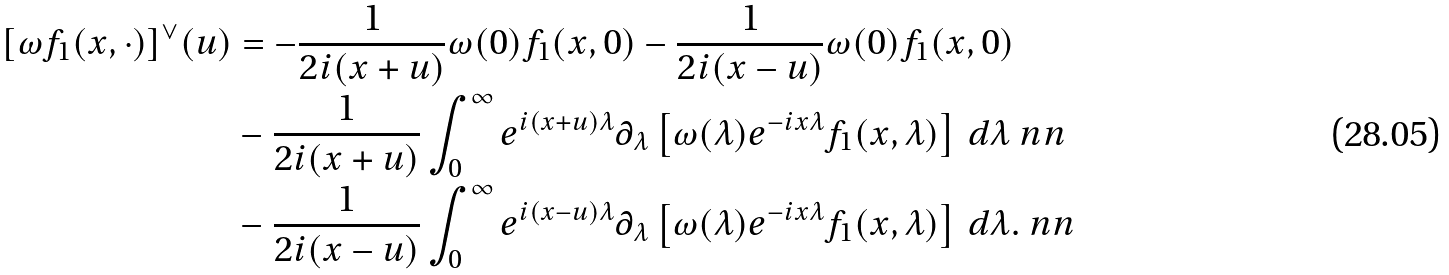<formula> <loc_0><loc_0><loc_500><loc_500>[ \omega f _ { 1 } ( x , \cdot ) ] ^ { \vee } ( u ) & = - \frac { 1 } { 2 i ( x + u ) } \omega ( 0 ) f _ { 1 } ( x , 0 ) - \frac { 1 } { 2 i ( x - u ) } \omega ( 0 ) f _ { 1 } ( x , 0 ) \\ & - \frac { 1 } { 2 i ( x + u ) } \int _ { 0 } ^ { \infty } e ^ { i ( x + u ) \lambda } \partial _ { \lambda } \left [ \omega ( \lambda ) e ^ { - i x \lambda } f _ { 1 } ( x , \lambda ) \right ] \, d \lambda \ n n \\ & - \frac { 1 } { 2 i ( x - u ) } \int _ { 0 } ^ { \infty } e ^ { i ( x - u ) \lambda } \partial _ { \lambda } \left [ \omega ( \lambda ) e ^ { - i x \lambda } f _ { 1 } ( x , \lambda ) \right ] \, d \lambda . \ n n</formula> 